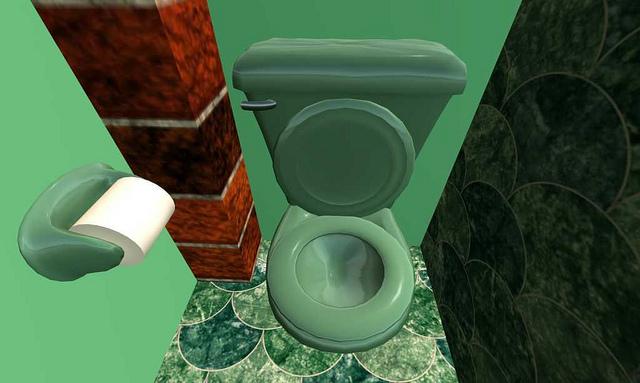What color are the toilet seats?
Keep it brief. Green. Is this a real bathroom?
Quick response, please. No. What color is the wall on the left?
Give a very brief answer. Green. Is the toilet in working order?
Write a very short answer. Yes. Is the toilet seat up?
Give a very brief answer. Yes. 